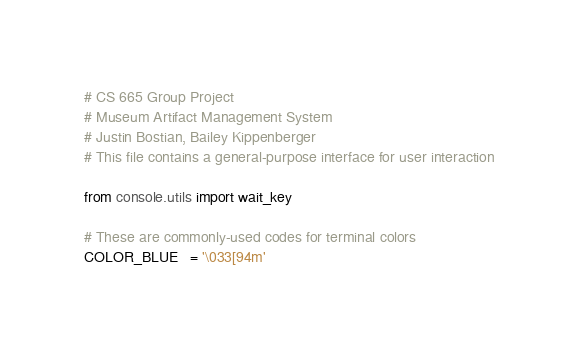Convert code to text. <code><loc_0><loc_0><loc_500><loc_500><_Python_># CS 665 Group Project
# Museum Artifact Management System
# Justin Bostian, Bailey Kippenberger
# This file contains a general-purpose interface for user interaction

from console.utils import wait_key

# These are commonly-used codes for terminal colors
COLOR_BLUE   = '\033[94m'</code> 